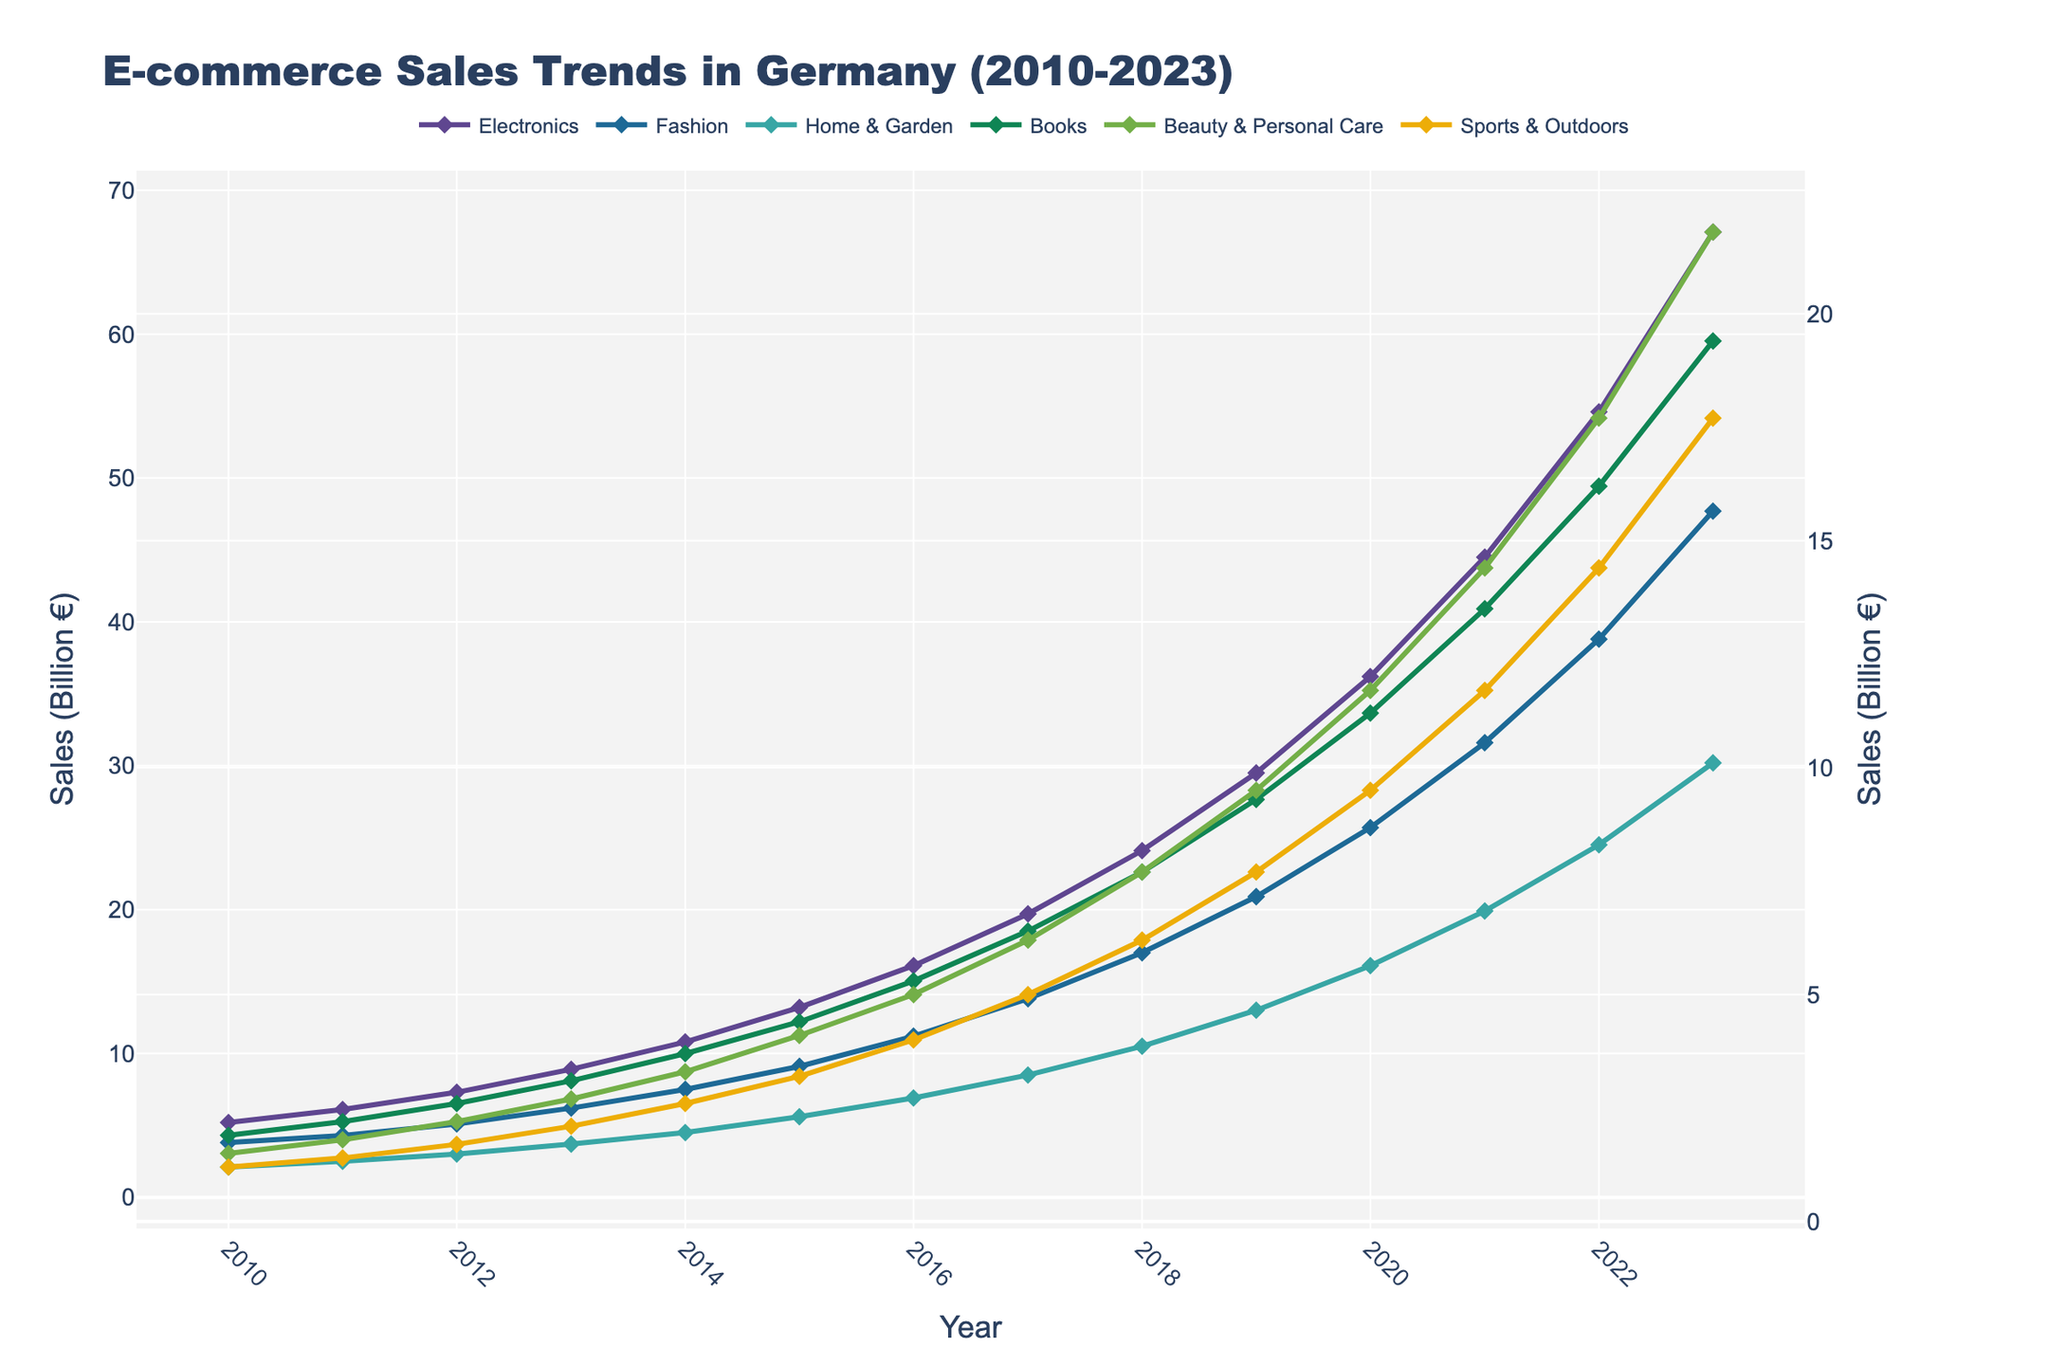When did Electronics sales surpass 10 billion euros? The Electronics sales line crosses the 10 billion euro mark between 2013 and 2014, right at 2014.
Answer: 2014 Which product category had the highest sales in 2023? Looking at the highest point of all lines in 2023, the Electronics category reaches 67.1 billion euros, higher than any other category.
Answer: Electronics How much did Beauty & Personal Care sales increase between 2010 and 2023? Subtract the 2010 value (1.5 billion euros) from the 2023 value (21.8 billion euros) for Beauty & Personal Care. 21.8 - 1.5 = 20.3 billion euros.
Answer: 20.3 billion euros What is the average sales in 2020 across all product categories? Add the sales values for each product category in 2020: 36.2 + 25.7 + 16.1 + 11.2 + 11.7 + 9.5 = 110.4. Then divide by the number of categories (6): 110.4 / 6 = 18.4 billion euros.
Answer: 18.4 billion euros Which two product categories had the closest sales values in 2018, and what were their sales? Compare the values for each category in 2018 to identify the closest pair: Electronics (24.1), Fashion (17.0), Home & Garden (10.5), Books (7.7), Beauty & Personal Care (7.7), Sports & Outdoors (6.2). Books and Beauty & Personal Care both have 7.7 billion euros.
Answer: Books and Beauty & Personal Care, 7.7 billion euros In what year did Fashion sales first exceed those of Home & Garden? Compare the values for Fashion and Home & Garden year by year until Fashion exceeds Home & Garden: This happens in 2013, where Fashion (6.2 billion euros) is higher than Home & Garden (3.7 billion euros).
Answer: 2013 What was the total increase in sales for Sports & Outdoors from 2010 to 2021? Subtract the 2010 value (1.2 billion euros) from the 2021 value (11.7 billion euros) for Sports & Outdoors: 11.7 - 1.2 = 10.5 billion euros.
Answer: 10.5 billion euros Which product category showed the most consistent sales growth over the period 2010-2023, and how can you tell? Observe the slope of each category's line; the Electronics category shows the most consistent increase in sales with a nearly steady upward trend.
Answer: Electronics What is the difference in sales between Electronics and Books in 2023? Subtract the Books sales in 2023 (19.4 billion euros) from the Electronics sales in 2023 (67.1 billion euros): 67.1 - 19.4 = 47.7 billion euros.
Answer: 47.7 billion euros 